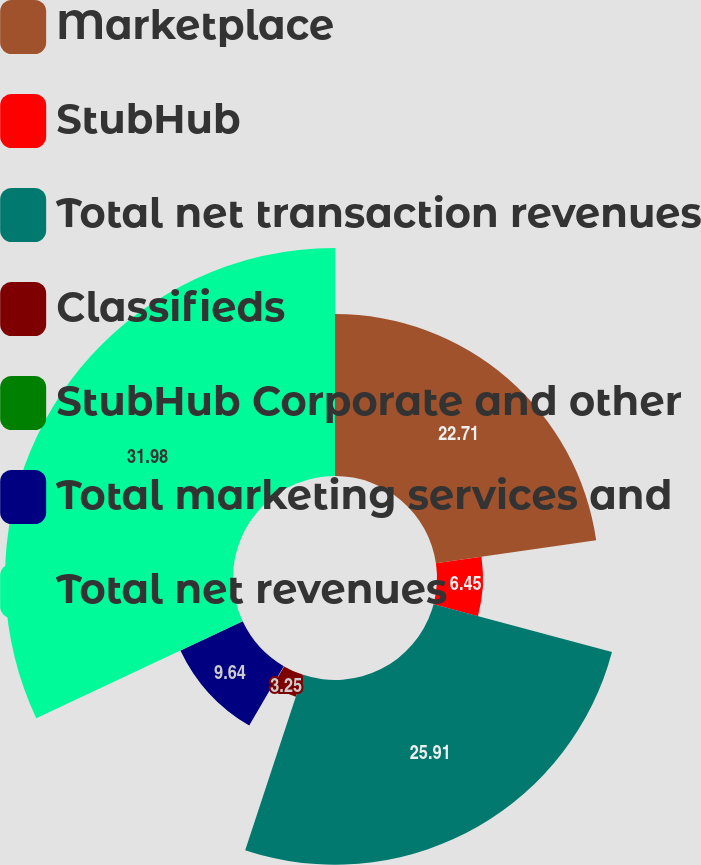Convert chart to OTSL. <chart><loc_0><loc_0><loc_500><loc_500><pie_chart><fcel>Marketplace<fcel>StubHub<fcel>Total net transaction revenues<fcel>Classifieds<fcel>StubHub Corporate and other<fcel>Total marketing services and<fcel>Total net revenues<nl><fcel>22.71%<fcel>6.45%<fcel>25.91%<fcel>3.25%<fcel>0.06%<fcel>9.64%<fcel>31.98%<nl></chart> 